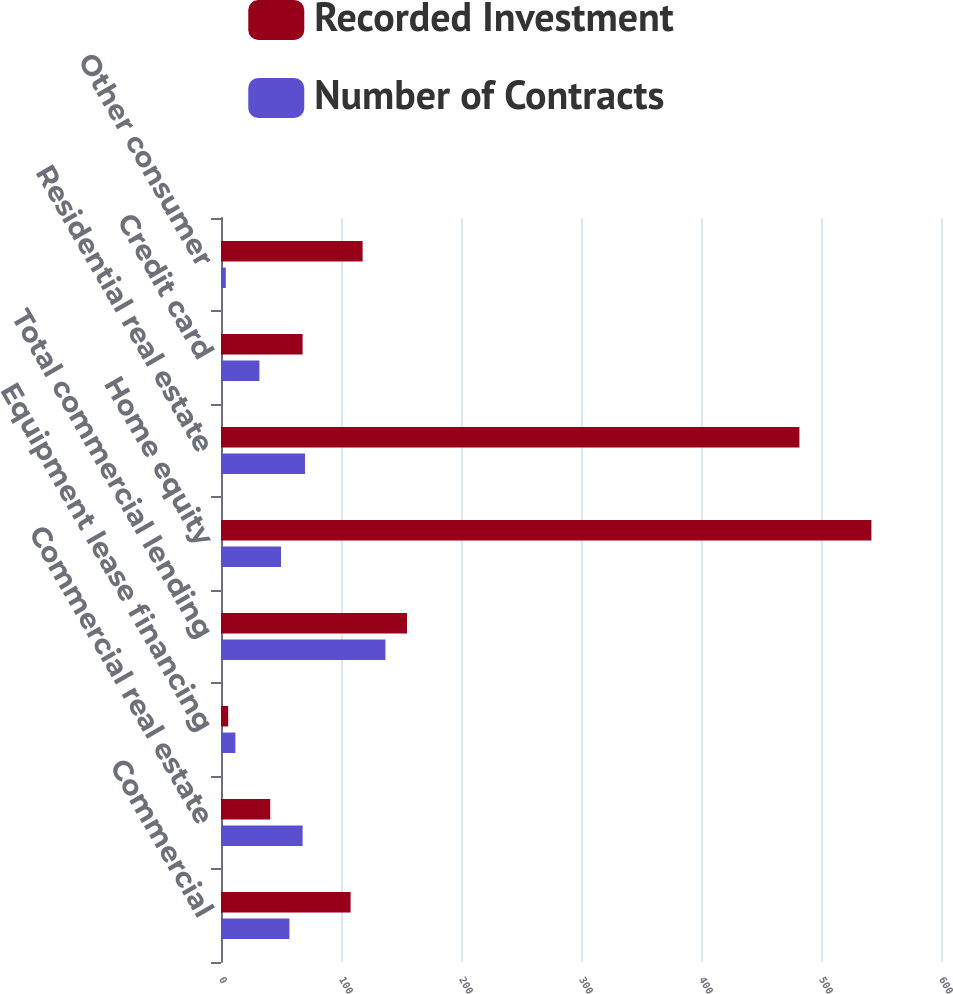Convert chart to OTSL. <chart><loc_0><loc_0><loc_500><loc_500><stacked_bar_chart><ecel><fcel>Commercial<fcel>Commercial real estate<fcel>Equipment lease financing<fcel>Total commercial lending<fcel>Home equity<fcel>Residential real estate<fcel>Credit card<fcel>Other consumer<nl><fcel>Recorded Investment<fcel>108<fcel>41<fcel>6<fcel>155<fcel>542<fcel>482<fcel>68<fcel>118<nl><fcel>Number of Contracts<fcel>57<fcel>68<fcel>12<fcel>137<fcel>50<fcel>70<fcel>32<fcel>4<nl></chart> 